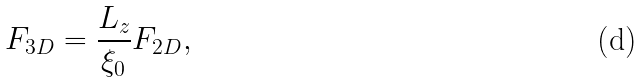<formula> <loc_0><loc_0><loc_500><loc_500>F _ { 3 D } = \frac { L _ { z } } { \xi _ { 0 } } F _ { 2 D } ,</formula> 